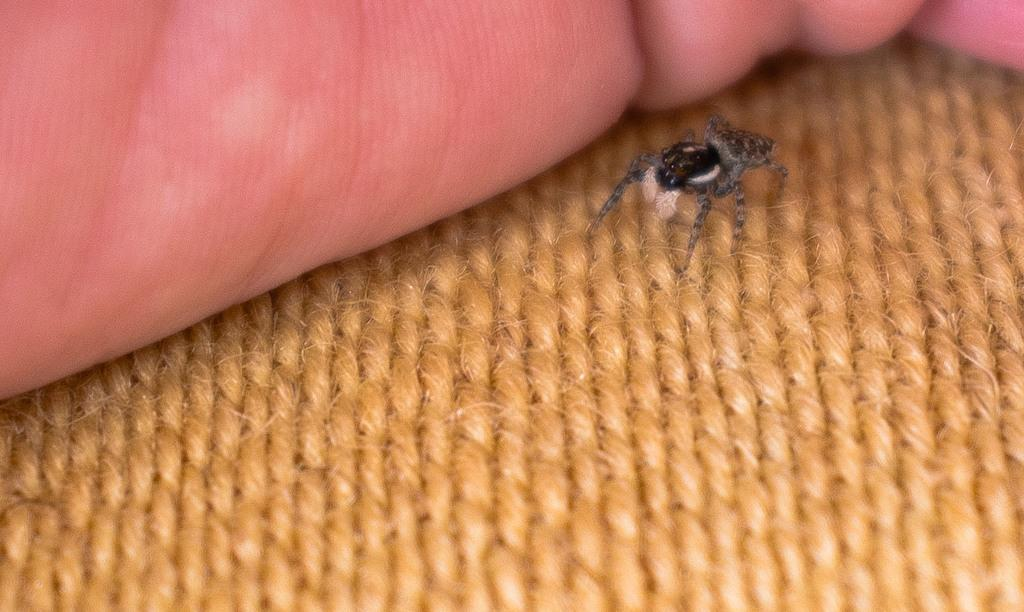What type of creature is present in the image? There is an insect in the image. Can you describe the colors of the insect? The insect has brown and gray colors. What else can be seen in the background of the image? There is a human hand in the background of the image. Is there a stream of water flowing near the insect in the image? No, there is no stream of water present in the image. Can you describe the texture of the leather in the image? There is no leather present in the image. 